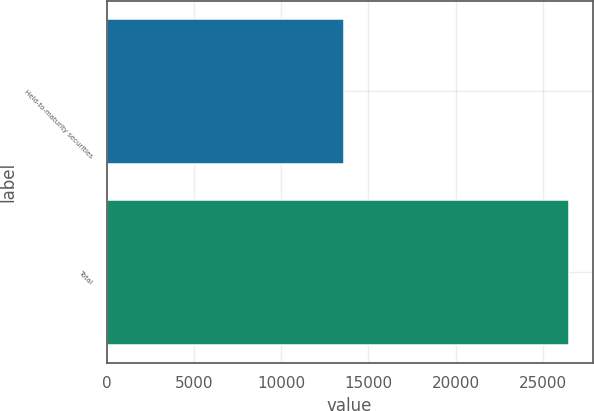Convert chart. <chart><loc_0><loc_0><loc_500><loc_500><bar_chart><fcel>Held-to-maturity securities<fcel>Total<nl><fcel>13613<fcel>26511<nl></chart> 